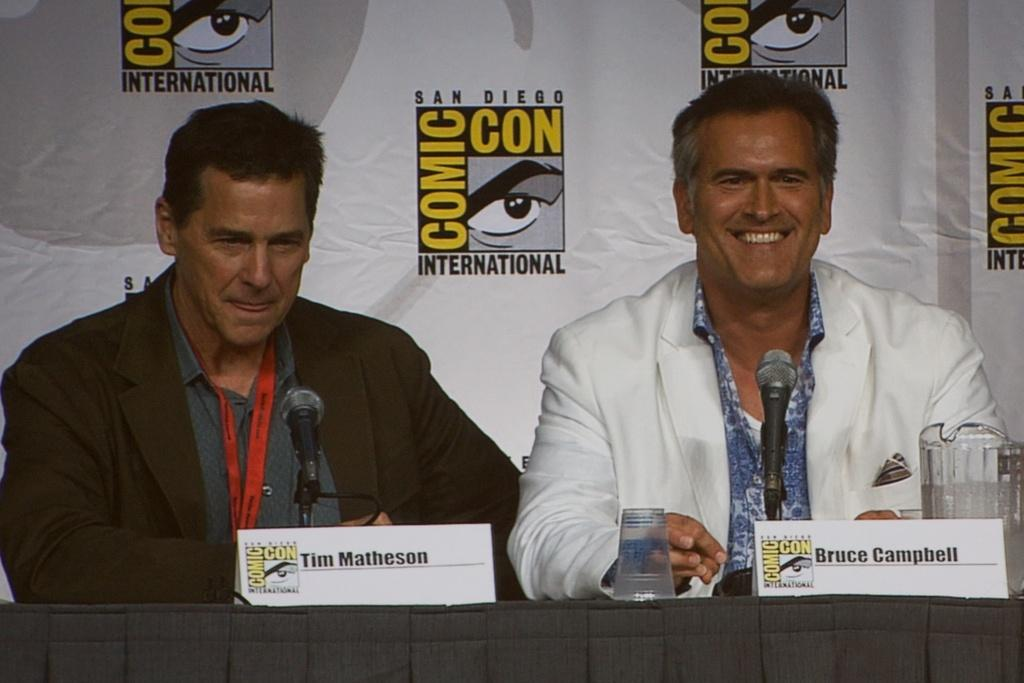How many people are sitting in the image? There are two people sitting on chairs in the image. What can be seen hanging in the image? There is a banner in the image. What piece of furniture is present in the image? There is a table in the image. What items are on the table? There are glasses and microphones (mics) on the table. What type of vegetable is being served on the table in the image? There is no vegetable present on the table in the image; only glasses and microphones are visible. Are there any mittens visible in the image? No, there are no mittens present in the image. 